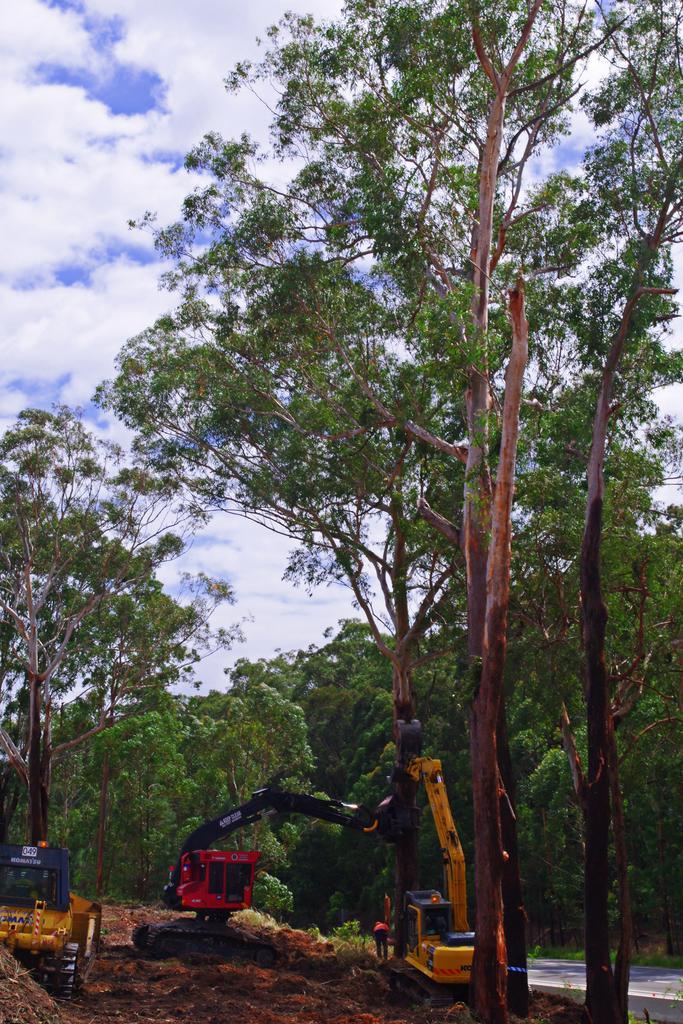Please provide a concise description of this image. In this image we can see the mobile cranes. Image also consists of many trees. We can also see the sky with the clouds. 